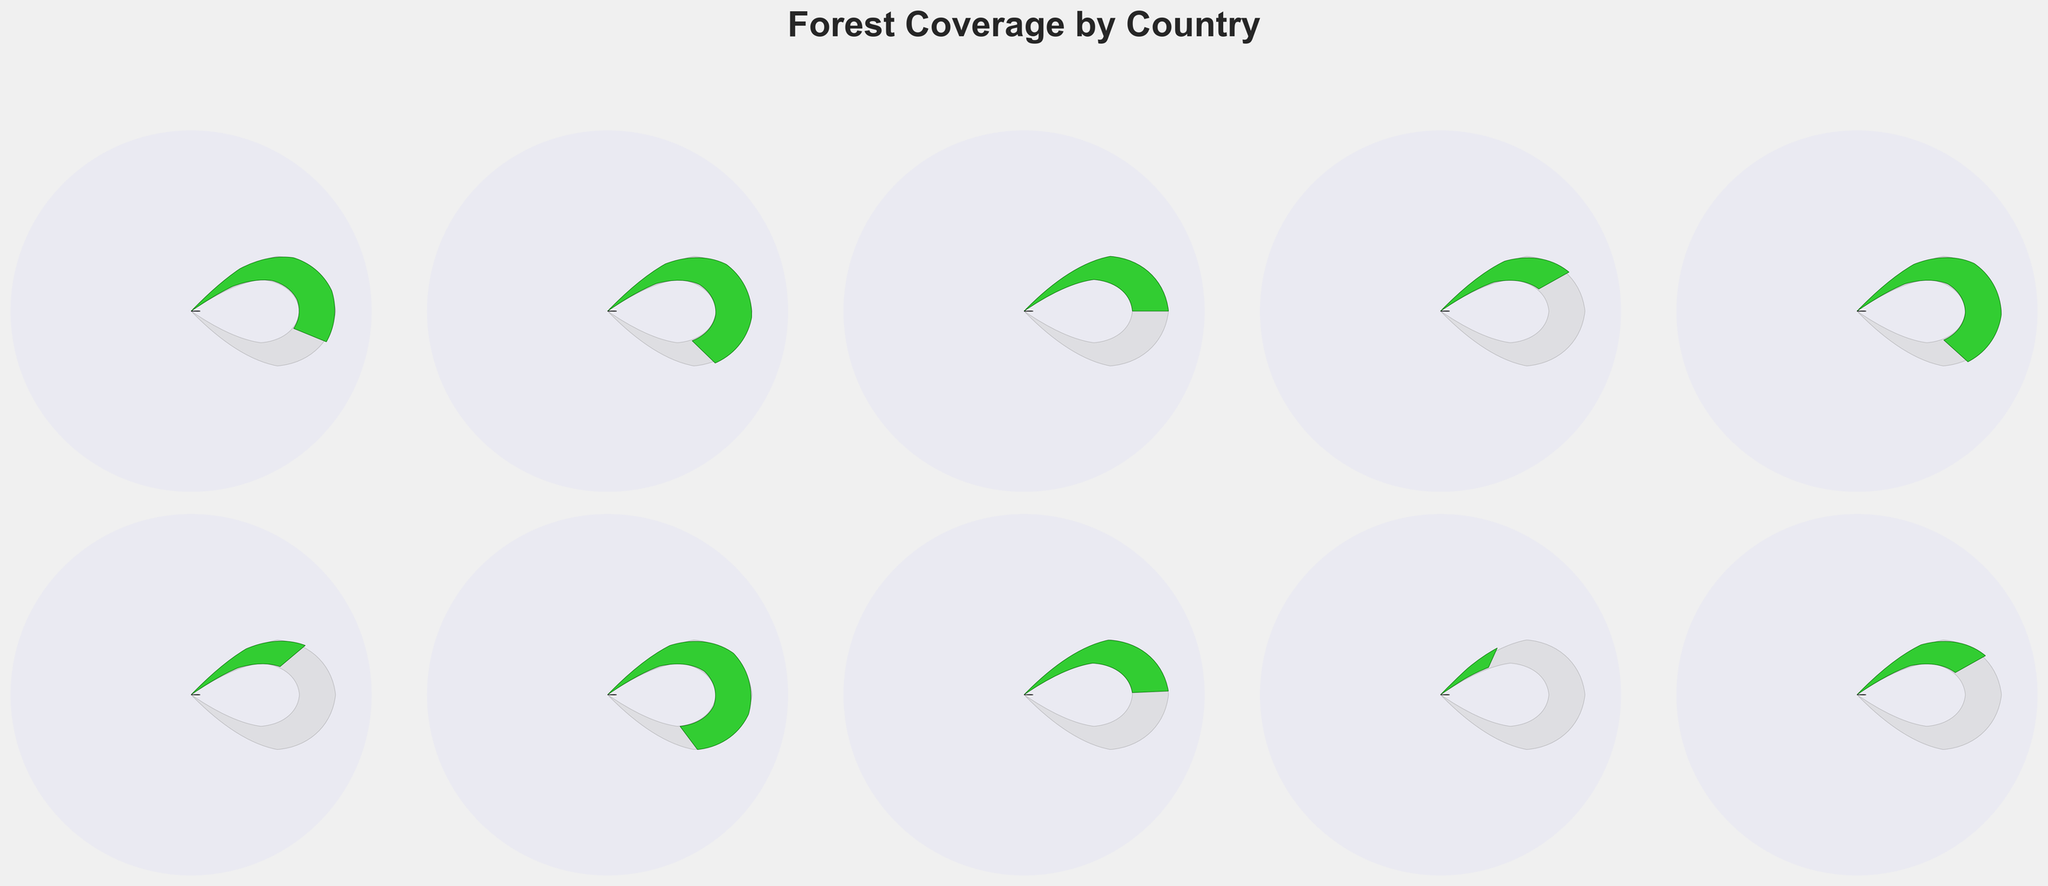What's the title of the figure? The title of the figure is located at the top center and is typically a clear summary of what the plot represents. Here, it reads "Forest Coverage by Country".
Answer: Forest Coverage by Country How many countries are represented in the figure? By counting the individual gauge charts, we can identify that each country has its own chart. There are two rows with five gauge charts each, totaling ten.
Answer: 10 Which country has the highest percentage of forest coverage? By comparing the gauge charts, Finland shows the highest fill within the gauge, denoting the highest percentage. Finland has 74% forest coverage.
Answer: Finland Which countries have less than 40% of their land area covered by forests? By observing the gauge fills and associated percentages, Canada (38%), United States (33%), and Australia (17%) have less than 40% forest coverage.
Answer: Canada, United States, Australia What is the average forest coverage percentage among the given countries? Adding up each forest coverage percentage (59 + 69 + 50 + 38 + 68 + 33 + 74 + 49 + 17 + 38) equals 495. Dividing by the number of countries, 10, gives an average of 49.5%.
Answer: 49.5% Which countries have forest coverage of more than 60%? Observing the gauge fill along with the percentages, Sweden (69%), Japan (68%), and Finland (74%) have forest coverage over 60%.
Answer: Sweden, Japan, Finland How does Brazil's forest coverage compare to Russia's? By examining the respective gauge charts, Brazil has 59% forest coverage, while Russia has 49%. So Brazil's coverage is 10% higher than Russia's.
Answer: Brazil has 10% more forest coverage than Russia Which country has the smallest percentage of forest coverage? By identifying the gauge chart with the least fill, Australia has the smallest forest coverage at 17%.
Answer: Australia What's the difference in forest coverage between Japan and the United States? By comparing the percentages, Japan has 68% and the United States has 33%. Subtracting these gives a difference of 35%.
Answer: 35% Which countries have forest coverage almost equal to 50%? By closely observing the gauges and their percentages, Indonesia (50%) and Russia (49%) are closest to 50%.
Answer: Indonesia, Russia 